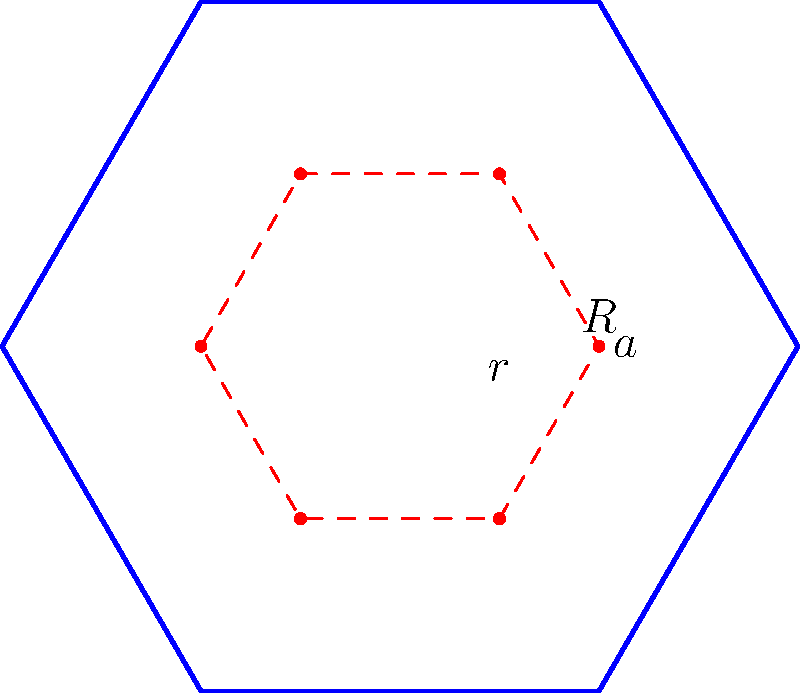You want to design a hexagonal tea garden to maximize the growing area within a given perimeter. If the perimeter of the garden is 60 meters, what is the maximum area you can achieve? Let's approach this step-by-step:

1) For a regular hexagon, if $a$ is the side length and $R$ is the radius of the circumscribed circle:

   $R = \frac{a}{\sqrt{3}}$

2) The area of a regular hexagon is:

   $A = \frac{3\sqrt{3}}{2}R^2 = \frac{3\sqrt{3}}{2}(\frac{a}{\sqrt{3}})^2 = \frac{3\sqrt{3}}{2} \cdot \frac{a^2}{3} = \frac{\sqrt{3}}{2}a^2$

3) The perimeter of the hexagon is $6a = 60$ meters, so $a = 10$ meters.

4) Substituting this into our area formula:

   $A = \frac{\sqrt{3}}{2}(10)^2 = 50\sqrt{3}$

5) To calculate the exact value:

   $50\sqrt{3} \approx 86.6025$ square meters

Therefore, the maximum area you can achieve with a perimeter of 60 meters is approximately 86.6025 square meters.
Answer: $50\sqrt{3}$ m² (or approximately 86.6025 m²) 